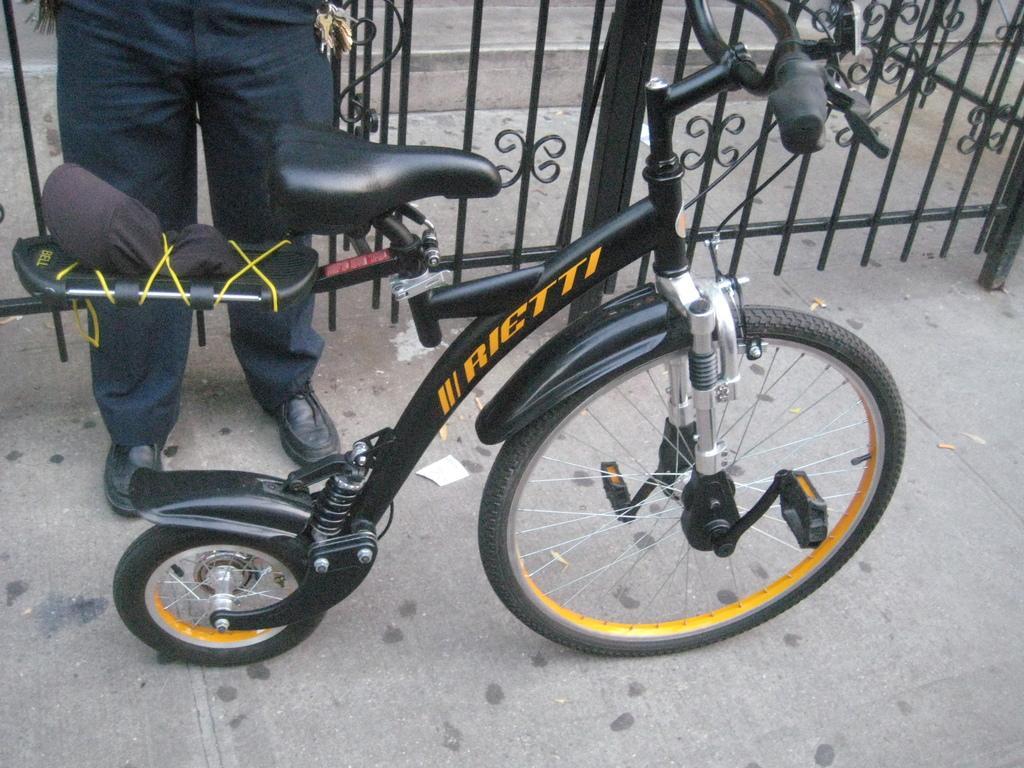How would you summarize this image in a sentence or two? In the image there is a cycle and there is a person standing in behind the cycle in front of the gate. 